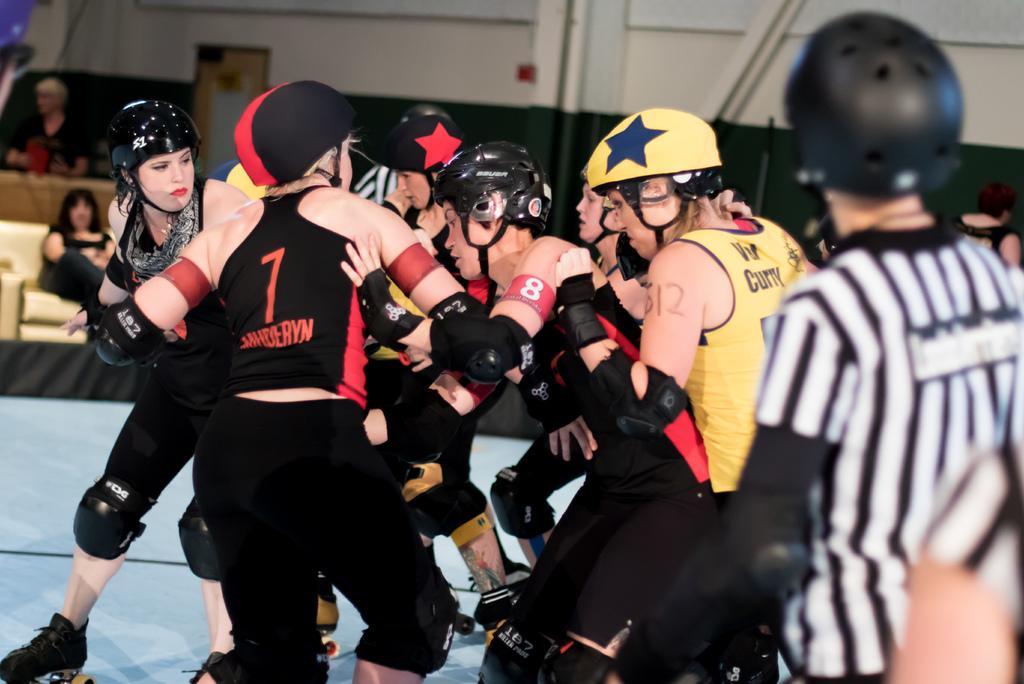Could you give a brief overview of what you see in this image? In the image we can see there are people standing on the ground and they are wearing roller skates and helmet. Behind there are other people sitting on the chair. 